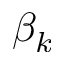Convert formula to latex. <formula><loc_0><loc_0><loc_500><loc_500>\beta _ { k }</formula> 